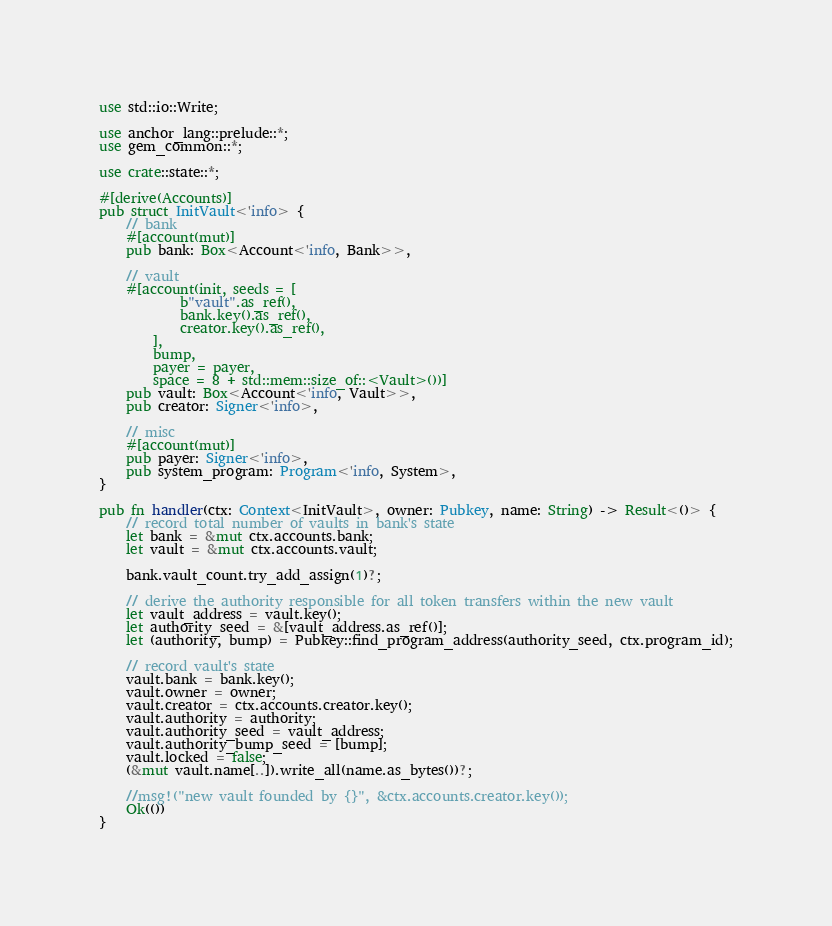<code> <loc_0><loc_0><loc_500><loc_500><_Rust_>use std::io::Write;

use anchor_lang::prelude::*;
use gem_common::*;

use crate::state::*;

#[derive(Accounts)]
pub struct InitVault<'info> {
    // bank
    #[account(mut)]
    pub bank: Box<Account<'info, Bank>>,

    // vault
    #[account(init, seeds = [
            b"vault".as_ref(),
            bank.key().as_ref(),
            creator.key().as_ref(),
        ],
        bump,
        payer = payer,
        space = 8 + std::mem::size_of::<Vault>())]
    pub vault: Box<Account<'info, Vault>>,
    pub creator: Signer<'info>,

    // misc
    #[account(mut)]
    pub payer: Signer<'info>,
    pub system_program: Program<'info, System>,
}

pub fn handler(ctx: Context<InitVault>, owner: Pubkey, name: String) -> Result<()> {
    // record total number of vaults in bank's state
    let bank = &mut ctx.accounts.bank;
    let vault = &mut ctx.accounts.vault;

    bank.vault_count.try_add_assign(1)?;

    // derive the authority responsible for all token transfers within the new vault
    let vault_address = vault.key();
    let authority_seed = &[vault_address.as_ref()];
    let (authority, bump) = Pubkey::find_program_address(authority_seed, ctx.program_id);

    // record vault's state
    vault.bank = bank.key();
    vault.owner = owner;
    vault.creator = ctx.accounts.creator.key();
    vault.authority = authority;
    vault.authority_seed = vault_address;
    vault.authority_bump_seed = [bump];
    vault.locked = false;
    (&mut vault.name[..]).write_all(name.as_bytes())?;

    //msg!("new vault founded by {}", &ctx.accounts.creator.key());
    Ok(())
}
</code> 